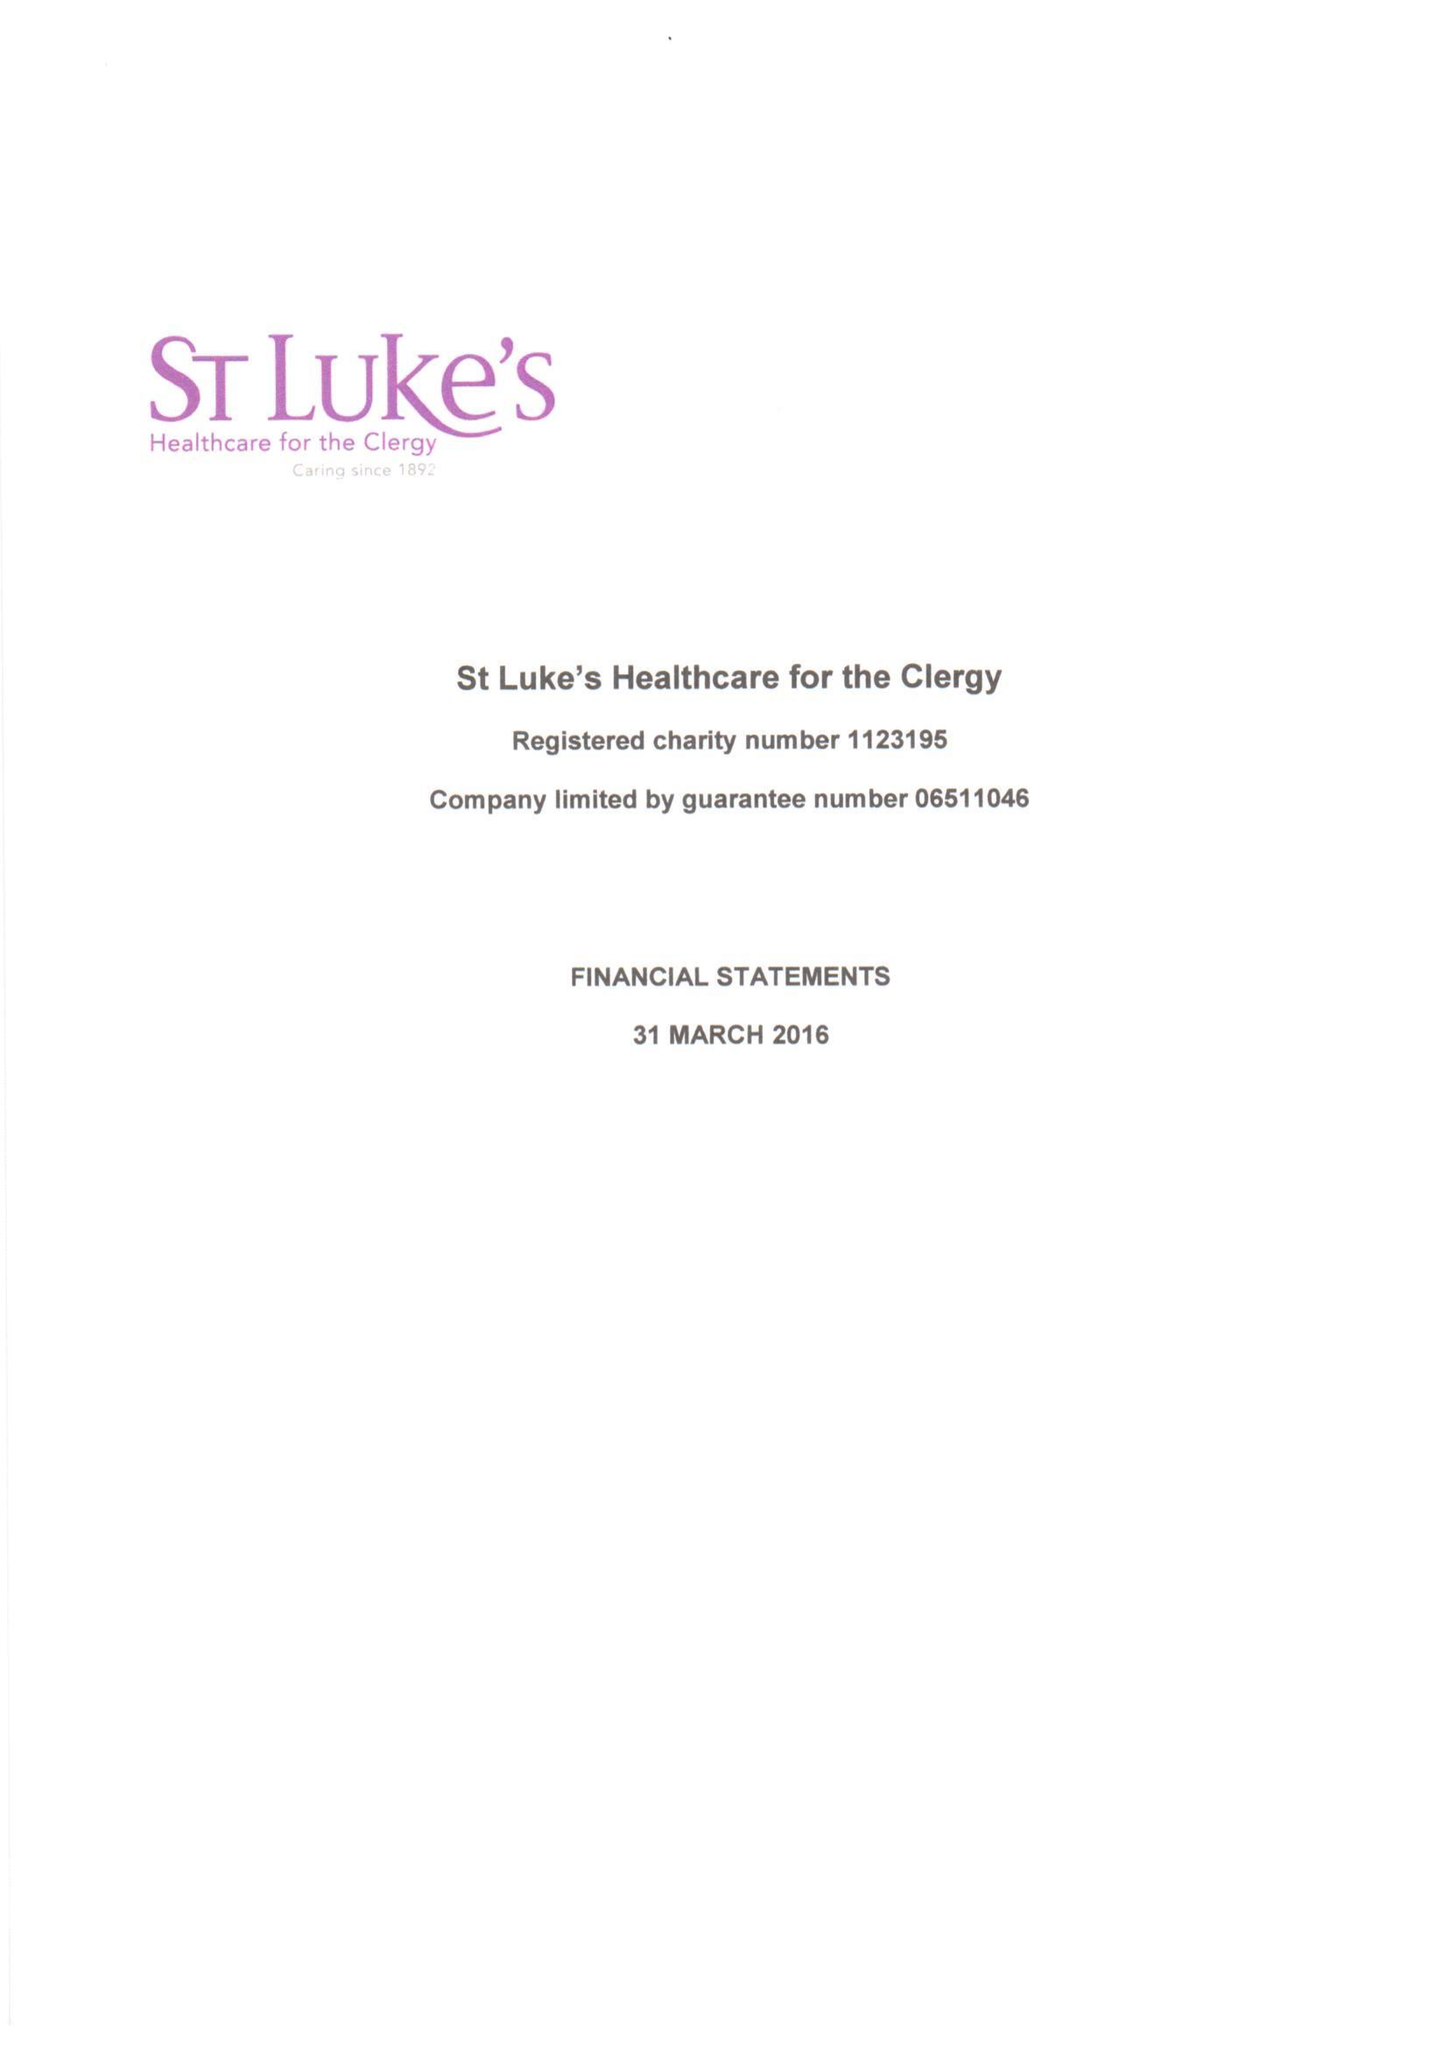What is the value for the report_date?
Answer the question using a single word or phrase. 2016-03-31 